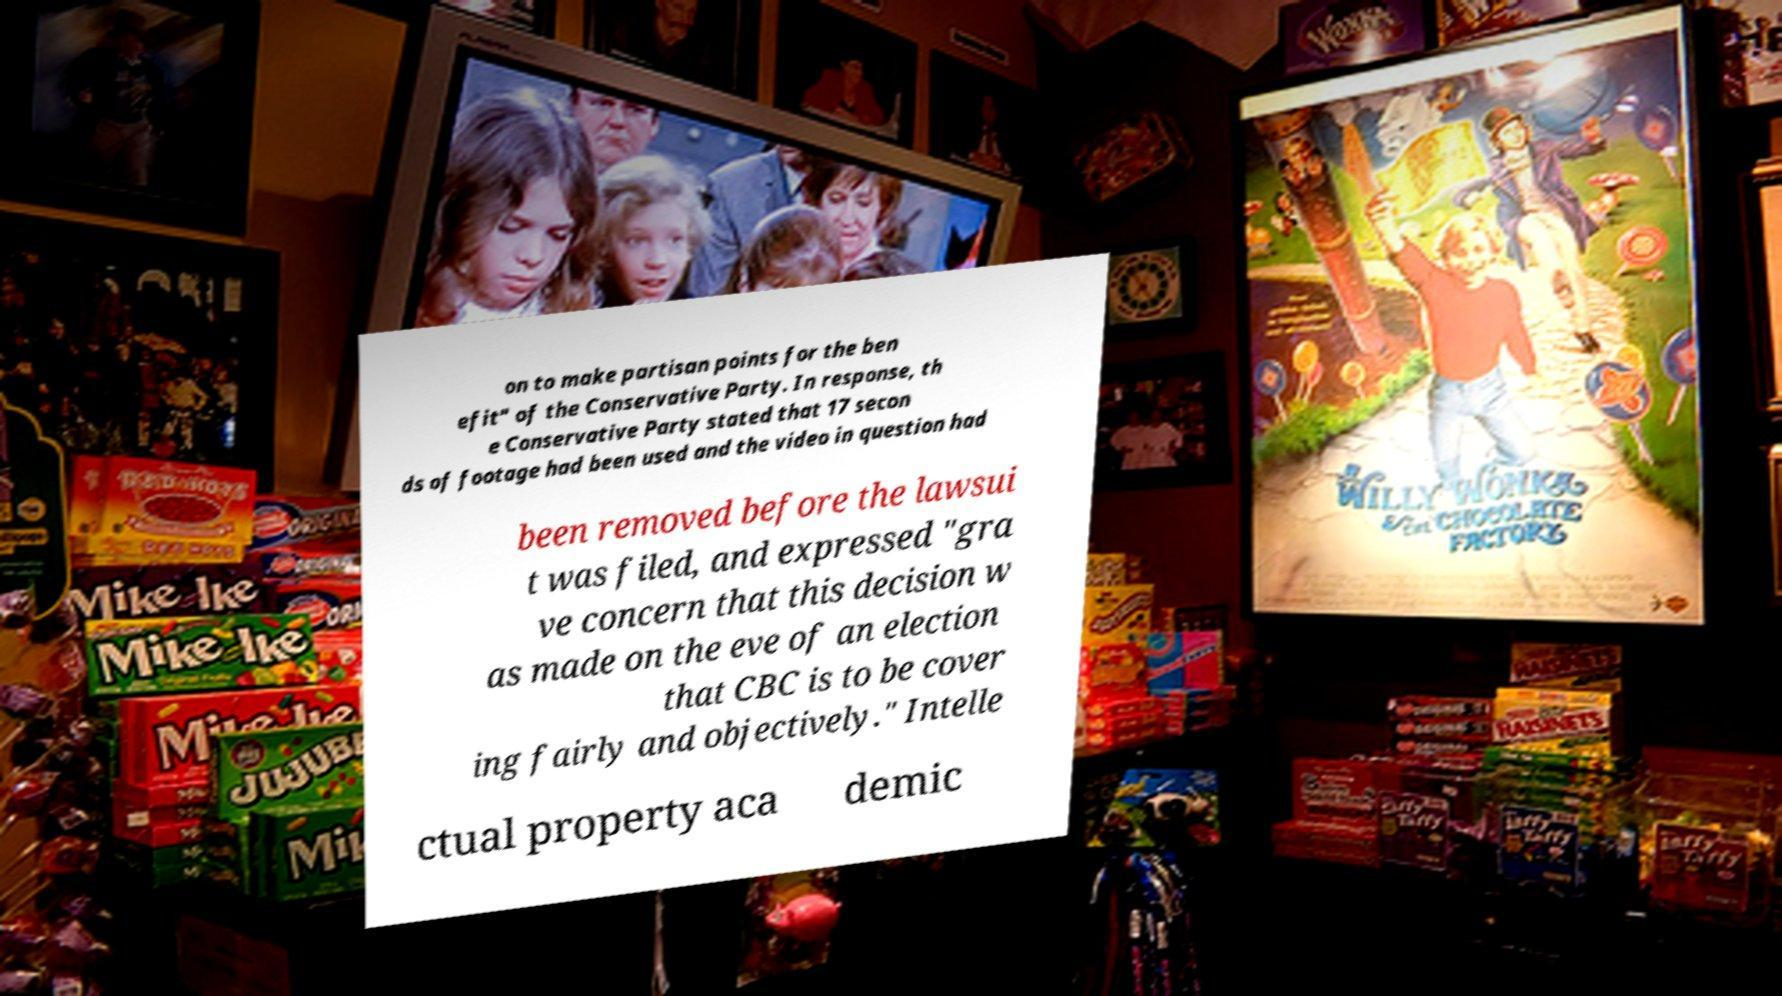Please identify and transcribe the text found in this image. on to make partisan points for the ben efit" of the Conservative Party. In response, th e Conservative Party stated that 17 secon ds of footage had been used and the video in question had been removed before the lawsui t was filed, and expressed "gra ve concern that this decision w as made on the eve of an election that CBC is to be cover ing fairly and objectively." Intelle ctual property aca demic 